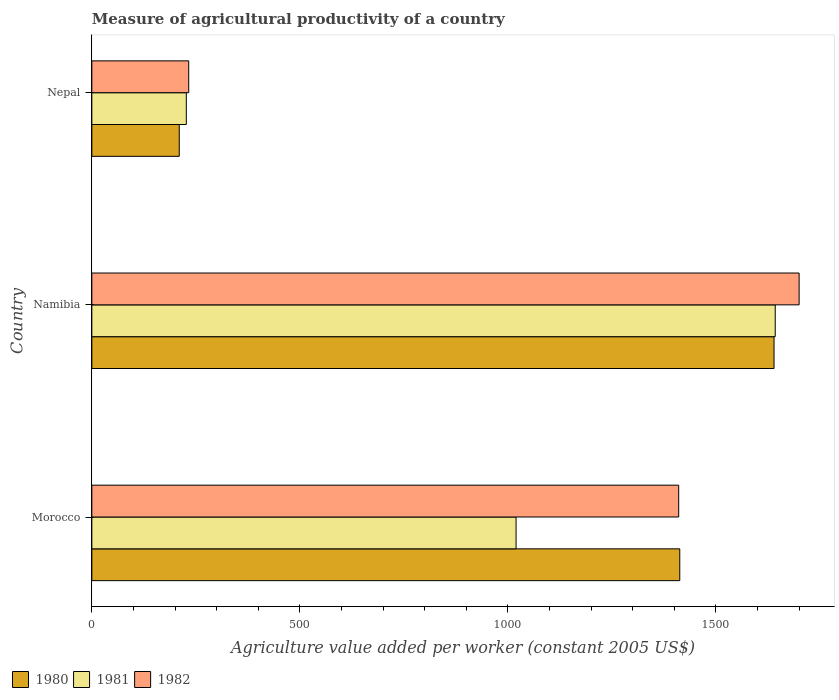How many different coloured bars are there?
Provide a short and direct response. 3. Are the number of bars per tick equal to the number of legend labels?
Provide a short and direct response. Yes. Are the number of bars on each tick of the Y-axis equal?
Provide a succinct answer. Yes. How many bars are there on the 2nd tick from the bottom?
Provide a short and direct response. 3. What is the label of the 2nd group of bars from the top?
Make the answer very short. Namibia. In how many cases, is the number of bars for a given country not equal to the number of legend labels?
Offer a terse response. 0. What is the measure of agricultural productivity in 1980 in Nepal?
Offer a terse response. 210.09. Across all countries, what is the maximum measure of agricultural productivity in 1980?
Your answer should be compact. 1639.69. Across all countries, what is the minimum measure of agricultural productivity in 1980?
Your answer should be very brief. 210.09. In which country was the measure of agricultural productivity in 1982 maximum?
Keep it short and to the point. Namibia. In which country was the measure of agricultural productivity in 1980 minimum?
Your response must be concise. Nepal. What is the total measure of agricultural productivity in 1981 in the graph?
Your answer should be very brief. 2889.26. What is the difference between the measure of agricultural productivity in 1982 in Namibia and that in Nepal?
Your answer should be very brief. 1467.16. What is the difference between the measure of agricultural productivity in 1982 in Namibia and the measure of agricultural productivity in 1980 in Nepal?
Ensure brevity in your answer.  1489.9. What is the average measure of agricultural productivity in 1982 per country?
Keep it short and to the point. 1114.44. What is the difference between the measure of agricultural productivity in 1981 and measure of agricultural productivity in 1980 in Morocco?
Your answer should be very brief. -393.45. In how many countries, is the measure of agricultural productivity in 1980 greater than 1000 US$?
Provide a short and direct response. 2. What is the ratio of the measure of agricultural productivity in 1982 in Namibia to that in Nepal?
Provide a short and direct response. 7.3. What is the difference between the highest and the second highest measure of agricultural productivity in 1982?
Ensure brevity in your answer.  289.5. What is the difference between the highest and the lowest measure of agricultural productivity in 1981?
Offer a very short reply. 1415.48. In how many countries, is the measure of agricultural productivity in 1981 greater than the average measure of agricultural productivity in 1981 taken over all countries?
Your response must be concise. 2. How many countries are there in the graph?
Your response must be concise. 3. What is the difference between two consecutive major ticks on the X-axis?
Make the answer very short. 500. Does the graph contain grids?
Your answer should be compact. No. How are the legend labels stacked?
Offer a very short reply. Horizontal. What is the title of the graph?
Provide a succinct answer. Measure of agricultural productivity of a country. What is the label or title of the X-axis?
Your response must be concise. Agriculture value added per worker (constant 2005 US$). What is the Agriculture value added per worker (constant 2005 US$) of 1980 in Morocco?
Give a very brief answer. 1413.09. What is the Agriculture value added per worker (constant 2005 US$) of 1981 in Morocco?
Make the answer very short. 1019.64. What is the Agriculture value added per worker (constant 2005 US$) in 1982 in Morocco?
Keep it short and to the point. 1410.49. What is the Agriculture value added per worker (constant 2005 US$) of 1980 in Namibia?
Provide a short and direct response. 1639.69. What is the Agriculture value added per worker (constant 2005 US$) of 1981 in Namibia?
Provide a succinct answer. 1642.55. What is the Agriculture value added per worker (constant 2005 US$) of 1982 in Namibia?
Make the answer very short. 1699.99. What is the Agriculture value added per worker (constant 2005 US$) of 1980 in Nepal?
Offer a very short reply. 210.09. What is the Agriculture value added per worker (constant 2005 US$) of 1981 in Nepal?
Offer a very short reply. 227.07. What is the Agriculture value added per worker (constant 2005 US$) in 1982 in Nepal?
Make the answer very short. 232.83. Across all countries, what is the maximum Agriculture value added per worker (constant 2005 US$) in 1980?
Give a very brief answer. 1639.69. Across all countries, what is the maximum Agriculture value added per worker (constant 2005 US$) in 1981?
Ensure brevity in your answer.  1642.55. Across all countries, what is the maximum Agriculture value added per worker (constant 2005 US$) in 1982?
Give a very brief answer. 1699.99. Across all countries, what is the minimum Agriculture value added per worker (constant 2005 US$) of 1980?
Make the answer very short. 210.09. Across all countries, what is the minimum Agriculture value added per worker (constant 2005 US$) in 1981?
Provide a succinct answer. 227.07. Across all countries, what is the minimum Agriculture value added per worker (constant 2005 US$) of 1982?
Your response must be concise. 232.83. What is the total Agriculture value added per worker (constant 2005 US$) of 1980 in the graph?
Offer a terse response. 3262.87. What is the total Agriculture value added per worker (constant 2005 US$) in 1981 in the graph?
Offer a terse response. 2889.26. What is the total Agriculture value added per worker (constant 2005 US$) in 1982 in the graph?
Provide a short and direct response. 3343.31. What is the difference between the Agriculture value added per worker (constant 2005 US$) of 1980 in Morocco and that in Namibia?
Make the answer very short. -226.6. What is the difference between the Agriculture value added per worker (constant 2005 US$) of 1981 in Morocco and that in Namibia?
Ensure brevity in your answer.  -622.91. What is the difference between the Agriculture value added per worker (constant 2005 US$) of 1982 in Morocco and that in Namibia?
Provide a succinct answer. -289.5. What is the difference between the Agriculture value added per worker (constant 2005 US$) of 1980 in Morocco and that in Nepal?
Provide a short and direct response. 1203. What is the difference between the Agriculture value added per worker (constant 2005 US$) in 1981 in Morocco and that in Nepal?
Ensure brevity in your answer.  792.57. What is the difference between the Agriculture value added per worker (constant 2005 US$) in 1982 in Morocco and that in Nepal?
Make the answer very short. 1177.66. What is the difference between the Agriculture value added per worker (constant 2005 US$) in 1980 in Namibia and that in Nepal?
Offer a very short reply. 1429.6. What is the difference between the Agriculture value added per worker (constant 2005 US$) of 1981 in Namibia and that in Nepal?
Offer a terse response. 1415.48. What is the difference between the Agriculture value added per worker (constant 2005 US$) in 1982 in Namibia and that in Nepal?
Give a very brief answer. 1467.16. What is the difference between the Agriculture value added per worker (constant 2005 US$) of 1980 in Morocco and the Agriculture value added per worker (constant 2005 US$) of 1981 in Namibia?
Your response must be concise. -229.46. What is the difference between the Agriculture value added per worker (constant 2005 US$) of 1980 in Morocco and the Agriculture value added per worker (constant 2005 US$) of 1982 in Namibia?
Keep it short and to the point. -286.9. What is the difference between the Agriculture value added per worker (constant 2005 US$) in 1981 in Morocco and the Agriculture value added per worker (constant 2005 US$) in 1982 in Namibia?
Offer a very short reply. -680.35. What is the difference between the Agriculture value added per worker (constant 2005 US$) in 1980 in Morocco and the Agriculture value added per worker (constant 2005 US$) in 1981 in Nepal?
Offer a terse response. 1186.02. What is the difference between the Agriculture value added per worker (constant 2005 US$) of 1980 in Morocco and the Agriculture value added per worker (constant 2005 US$) of 1982 in Nepal?
Your answer should be very brief. 1180.26. What is the difference between the Agriculture value added per worker (constant 2005 US$) in 1981 in Morocco and the Agriculture value added per worker (constant 2005 US$) in 1982 in Nepal?
Provide a succinct answer. 786.81. What is the difference between the Agriculture value added per worker (constant 2005 US$) of 1980 in Namibia and the Agriculture value added per worker (constant 2005 US$) of 1981 in Nepal?
Make the answer very short. 1412.62. What is the difference between the Agriculture value added per worker (constant 2005 US$) of 1980 in Namibia and the Agriculture value added per worker (constant 2005 US$) of 1982 in Nepal?
Provide a short and direct response. 1406.86. What is the difference between the Agriculture value added per worker (constant 2005 US$) of 1981 in Namibia and the Agriculture value added per worker (constant 2005 US$) of 1982 in Nepal?
Your answer should be very brief. 1409.72. What is the average Agriculture value added per worker (constant 2005 US$) in 1980 per country?
Keep it short and to the point. 1087.62. What is the average Agriculture value added per worker (constant 2005 US$) in 1981 per country?
Offer a very short reply. 963.09. What is the average Agriculture value added per worker (constant 2005 US$) of 1982 per country?
Offer a very short reply. 1114.44. What is the difference between the Agriculture value added per worker (constant 2005 US$) of 1980 and Agriculture value added per worker (constant 2005 US$) of 1981 in Morocco?
Your answer should be very brief. 393.45. What is the difference between the Agriculture value added per worker (constant 2005 US$) of 1980 and Agriculture value added per worker (constant 2005 US$) of 1982 in Morocco?
Your answer should be very brief. 2.6. What is the difference between the Agriculture value added per worker (constant 2005 US$) of 1981 and Agriculture value added per worker (constant 2005 US$) of 1982 in Morocco?
Offer a very short reply. -390.85. What is the difference between the Agriculture value added per worker (constant 2005 US$) in 1980 and Agriculture value added per worker (constant 2005 US$) in 1981 in Namibia?
Keep it short and to the point. -2.86. What is the difference between the Agriculture value added per worker (constant 2005 US$) of 1980 and Agriculture value added per worker (constant 2005 US$) of 1982 in Namibia?
Make the answer very short. -60.3. What is the difference between the Agriculture value added per worker (constant 2005 US$) in 1981 and Agriculture value added per worker (constant 2005 US$) in 1982 in Namibia?
Provide a succinct answer. -57.44. What is the difference between the Agriculture value added per worker (constant 2005 US$) of 1980 and Agriculture value added per worker (constant 2005 US$) of 1981 in Nepal?
Provide a succinct answer. -16.98. What is the difference between the Agriculture value added per worker (constant 2005 US$) in 1980 and Agriculture value added per worker (constant 2005 US$) in 1982 in Nepal?
Keep it short and to the point. -22.74. What is the difference between the Agriculture value added per worker (constant 2005 US$) in 1981 and Agriculture value added per worker (constant 2005 US$) in 1982 in Nepal?
Your answer should be compact. -5.76. What is the ratio of the Agriculture value added per worker (constant 2005 US$) in 1980 in Morocco to that in Namibia?
Offer a terse response. 0.86. What is the ratio of the Agriculture value added per worker (constant 2005 US$) in 1981 in Morocco to that in Namibia?
Keep it short and to the point. 0.62. What is the ratio of the Agriculture value added per worker (constant 2005 US$) in 1982 in Morocco to that in Namibia?
Make the answer very short. 0.83. What is the ratio of the Agriculture value added per worker (constant 2005 US$) in 1980 in Morocco to that in Nepal?
Your response must be concise. 6.73. What is the ratio of the Agriculture value added per worker (constant 2005 US$) in 1981 in Morocco to that in Nepal?
Offer a terse response. 4.49. What is the ratio of the Agriculture value added per worker (constant 2005 US$) of 1982 in Morocco to that in Nepal?
Your answer should be very brief. 6.06. What is the ratio of the Agriculture value added per worker (constant 2005 US$) of 1980 in Namibia to that in Nepal?
Your response must be concise. 7.8. What is the ratio of the Agriculture value added per worker (constant 2005 US$) in 1981 in Namibia to that in Nepal?
Provide a succinct answer. 7.23. What is the ratio of the Agriculture value added per worker (constant 2005 US$) of 1982 in Namibia to that in Nepal?
Provide a succinct answer. 7.3. What is the difference between the highest and the second highest Agriculture value added per worker (constant 2005 US$) in 1980?
Make the answer very short. 226.6. What is the difference between the highest and the second highest Agriculture value added per worker (constant 2005 US$) of 1981?
Make the answer very short. 622.91. What is the difference between the highest and the second highest Agriculture value added per worker (constant 2005 US$) in 1982?
Your answer should be compact. 289.5. What is the difference between the highest and the lowest Agriculture value added per worker (constant 2005 US$) in 1980?
Give a very brief answer. 1429.6. What is the difference between the highest and the lowest Agriculture value added per worker (constant 2005 US$) of 1981?
Your response must be concise. 1415.48. What is the difference between the highest and the lowest Agriculture value added per worker (constant 2005 US$) in 1982?
Your answer should be very brief. 1467.16. 